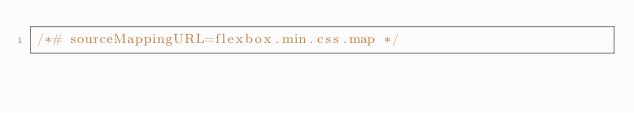<code> <loc_0><loc_0><loc_500><loc_500><_CSS_>/*# sourceMappingURL=flexbox.min.css.map */</code> 